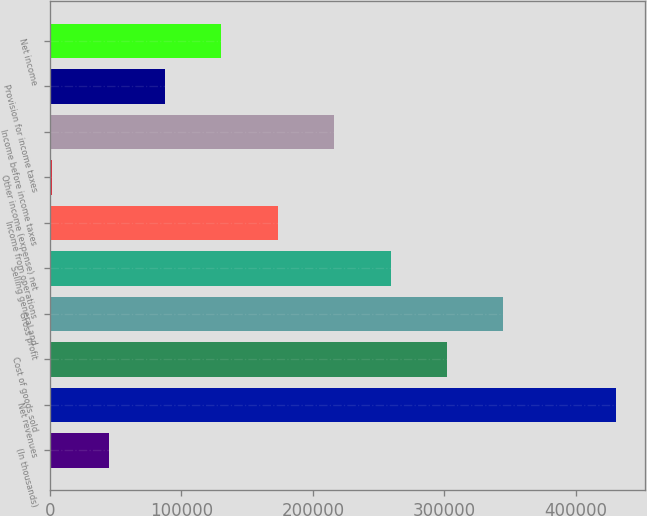Convert chart to OTSL. <chart><loc_0><loc_0><loc_500><loc_500><bar_chart><fcel>(In thousands)<fcel>Net revenues<fcel>Cost of goods sold<fcel>Gross profit<fcel>Selling general and<fcel>Income from operations<fcel>Other income (expense) net<fcel>Income before income taxes<fcel>Provision for income taxes<fcel>Net income<nl><fcel>44697.9<fcel>430689<fcel>302025<fcel>344913<fcel>259137<fcel>173362<fcel>1810<fcel>216250<fcel>87585.8<fcel>130474<nl></chart> 